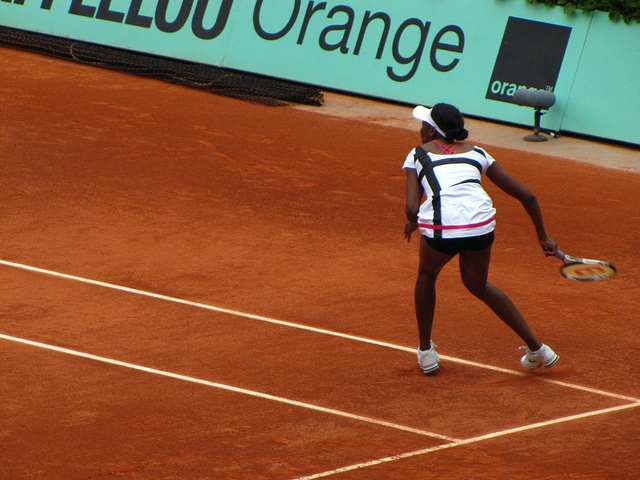Describe the objects in this image and their specific colors. I can see people in turquoise, black, white, maroon, and brown tones and tennis racket in turquoise, brown, gray, maroon, and black tones in this image. 